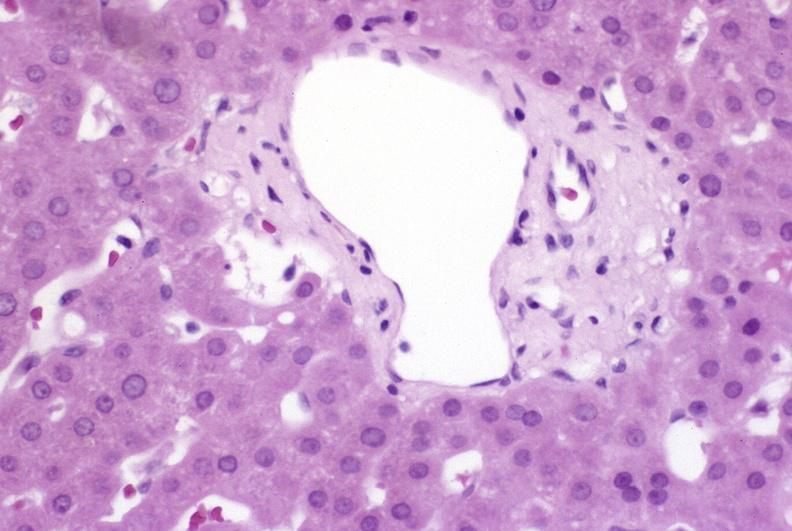what is present?
Answer the question using a single word or phrase. Liver 